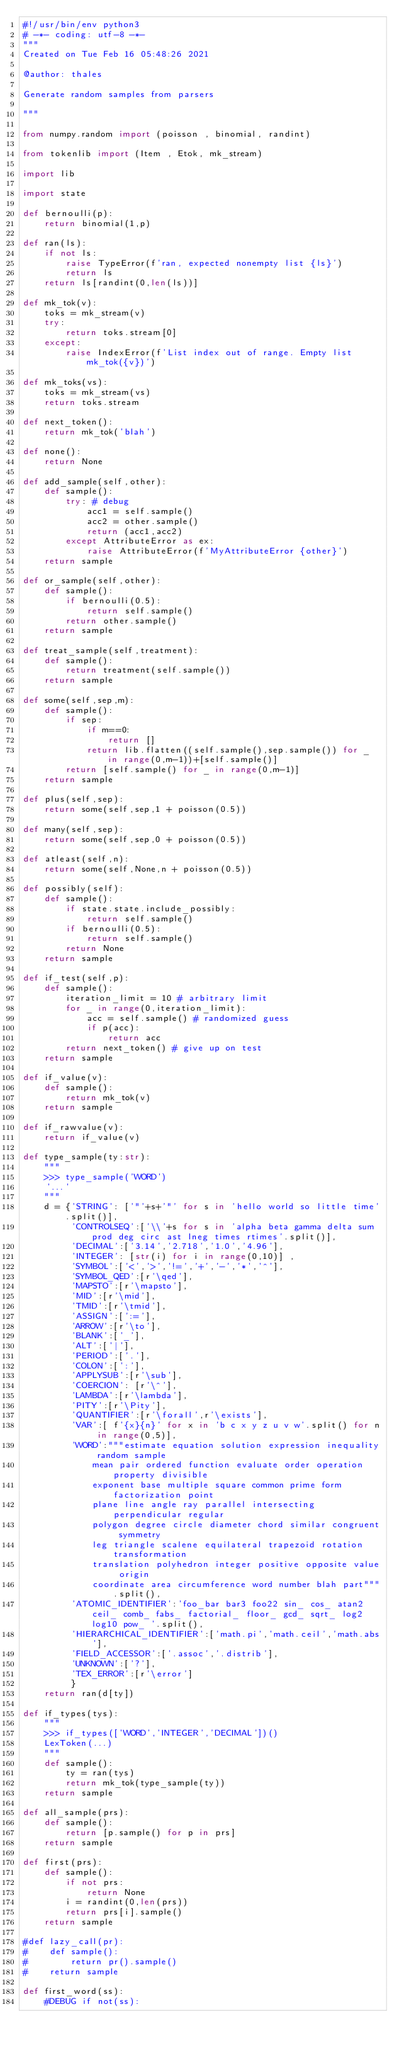Convert code to text. <code><loc_0><loc_0><loc_500><loc_500><_Python_>#!/usr/bin/env python3
# -*- coding: utf-8 -*-
"""
Created on Tue Feb 16 05:48:26 2021

@author: thales

Generate random samples from parsers

"""

from numpy.random import (poisson , binomial, randint)

from tokenlib import (Item , Etok, mk_stream)

import lib

import state

def bernoulli(p):
    return binomial(1,p)

def ran(ls):
    if not ls:
        raise TypeError(f'ran, expected nonempty list {ls}')
        return ls
    return ls[randint(0,len(ls))]

def mk_tok(v):
    toks = mk_stream(v)
    try: 
        return toks.stream[0]
    except:
        raise IndexError(f'List index out of range. Empty list mk_tok({v})')
        
def mk_toks(vs):
    toks = mk_stream(vs)
    return toks.stream

def next_token():
    return mk_tok('blah')

def none():
    return None

def add_sample(self,other):
    def sample():
        try: # debug
            acc1 = self.sample()
            acc2 = other.sample()
            return (acc1,acc2)
        except AttributeError as ex:
            raise AttributeError(f'MyAttributeError {other}')
    return sample

def or_sample(self,other):
    def sample():
        if bernoulli(0.5):
            return self.sample()
        return other.sample()
    return sample

def treat_sample(self,treatment):
    def sample():
        return treatment(self.sample())
    return sample 

def some(self,sep,m):
    def sample():
        if sep:
            if m==0:
                return []
            return lib.flatten((self.sample(),sep.sample()) for _ in range(0,m-1))+[self.sample()]
        return [self.sample() for _ in range(0,m-1)]
    return sample

def plus(self,sep):
    return some(self,sep,1 + poisson(0.5))
         
def many(self,sep):
    return some(self,sep,0 + poisson(0.5))

def atleast(self,n):
    return some(self,None,n + poisson(0.5))

def possibly(self):
    def sample():
        if state.state.include_possibly:
            return self.sample()
        if bernoulli(0.5):
            return self.sample()
        return None
    return sample

def if_test(self,p):
    def sample():
        iteration_limit = 10 # arbitrary limit
        for _ in range(0,iteration_limit):
            acc = self.sample() # randomized guess
            if p(acc):
                return acc 
        return next_token() # give up on test
    return sample

def if_value(v):
    def sample():
        return mk_tok(v)
    return sample

def if_rawvalue(v):
    return if_value(v)

def type_sample(ty:str):
    """ 
    >>> type_sample('WORD')
    '...'
    """
    d = {'STRING': ['"'+s+'"' for s in 'hello world so little time'.split()],
         'CONTROLSEQ':['\\'+s for s in 'alpha beta gamma delta sum prod deg circ ast lneg times rtimes'.split()],
         'DECIMAL':['3.14','2.718','1.0','4.96'],
         'INTEGER': [str(i) for i in range(0,10)] ,
         'SYMBOL':['<','>','!=','+','-','*','^'],
         'SYMBOL_QED':[r'\qed'],
         'MAPSTO':[r'\mapsto'],
         'MID':[r'\mid'],
         'TMID':[r'\tmid'],
         'ASSIGN':[':='],
         'ARROW':[r'\to'],
         'BLANK':['_'],
         'ALT':['|'],
         'PERIOD':['.'],
         'COLON':[':'],
         'APPLYSUB':[r'\sub'],
         'COERCION': [r'\^'],
         'LAMBDA':[r'\lambda'],
         'PITY':[r'\Pity'],
         'QUANTIFIER':[r'\forall',r'\exists'],
         'VAR':[ f'{x}{n}' for x in 'b c x y z u v w'.split() for n in range(0,5)],
         'WORD':"""estimate equation solution expression inequality random sample 
             mean pair ordered function evaluate order operation property divisible 
             exponent base multiple square common prime form factorization point 
             plane line angle ray parallel intersecting perpendicular regular 
             polygon degree circle diameter chord similar congruent symmetry 
             leg triangle scalene equilateral trapezoid rotation transformation 
             translation polyhedron integer positive opposite value origin 
             coordinate area circumference word number blah part""".split(),
         'ATOMIC_IDENTIFIER':'foo_bar bar3 foo22 sin_ cos_ atan2 ceil_ comb_ fabs_ factorial_ floor_ gcd_ sqrt_ log2 log10 pow_ '.split(),
         'HIERARCHICAL_IDENTIFIER':['math.pi','math.ceil','math.abs'],
         'FIELD_ACCESSOR':['.assoc','.distrib'],
         'UNKNOWN':['?'],
         'TEX_ERROR':[r'\error']
         }
    return ran(d[ty])

def if_types(tys):
    """ 
    >>> if_types(['WORD','INTEGER','DECIMAL'])()
    LexToken(...)
    """
    def sample():
        ty = ran(tys)
        return mk_tok(type_sample(ty))
    return sample

def all_sample(prs):
    def sample():
        return [p.sample() for p in prs]
    return sample

def first(prs):
    def sample():
        if not prs:
            return None
        i = randint(0,len(prs))
        return prs[i].sample()
    return sample

#def lazy_call(pr):
#    def sample():
#        return pr().sample()
#    return sample

def first_word(ss):
    #DEBUG if not(ss):</code> 